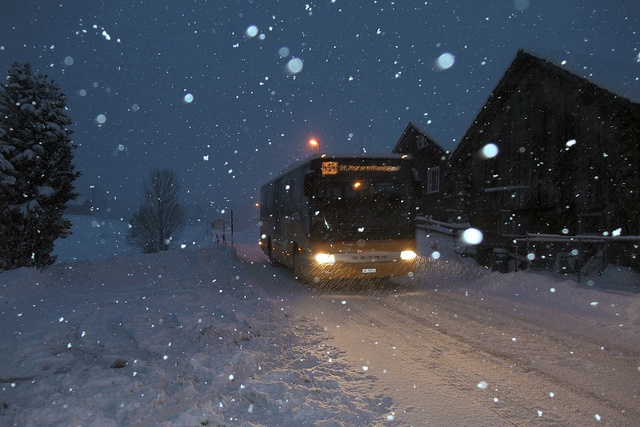Describe the objects in this image and their specific colors. I can see bus in darkblue, black, maroon, and gray tones in this image. 